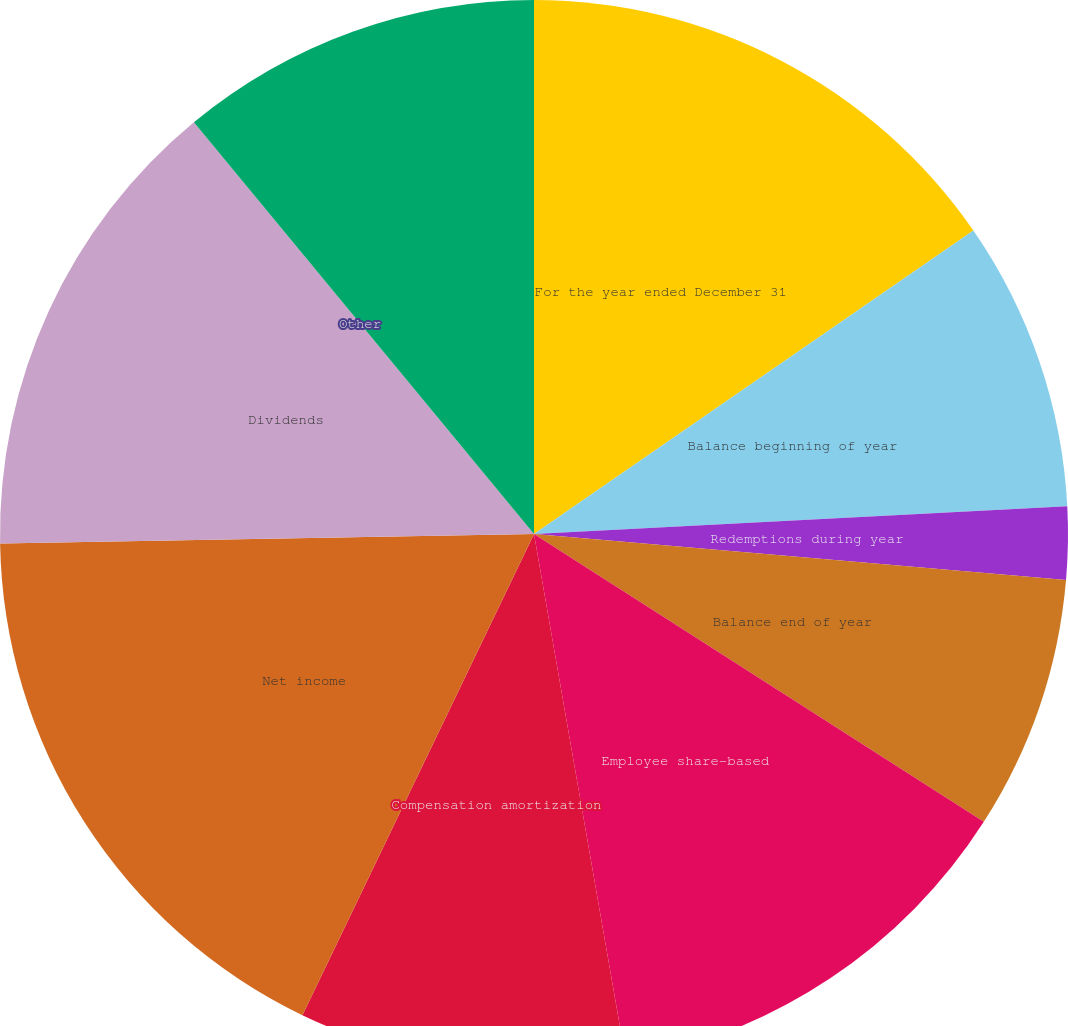<chart> <loc_0><loc_0><loc_500><loc_500><pie_chart><fcel>For the year ended December 31<fcel>Balance beginning of year<fcel>Redemptions during year<fcel>Balance end of year<fcel>Employee share-based<fcel>Compensation amortization<fcel>Net income<fcel>Dividends<fcel>Other<fcel>Change in net unrealized gain<nl><fcel>15.38%<fcel>8.79%<fcel>2.2%<fcel>7.69%<fcel>13.19%<fcel>9.89%<fcel>17.58%<fcel>14.29%<fcel>0.0%<fcel>10.99%<nl></chart> 